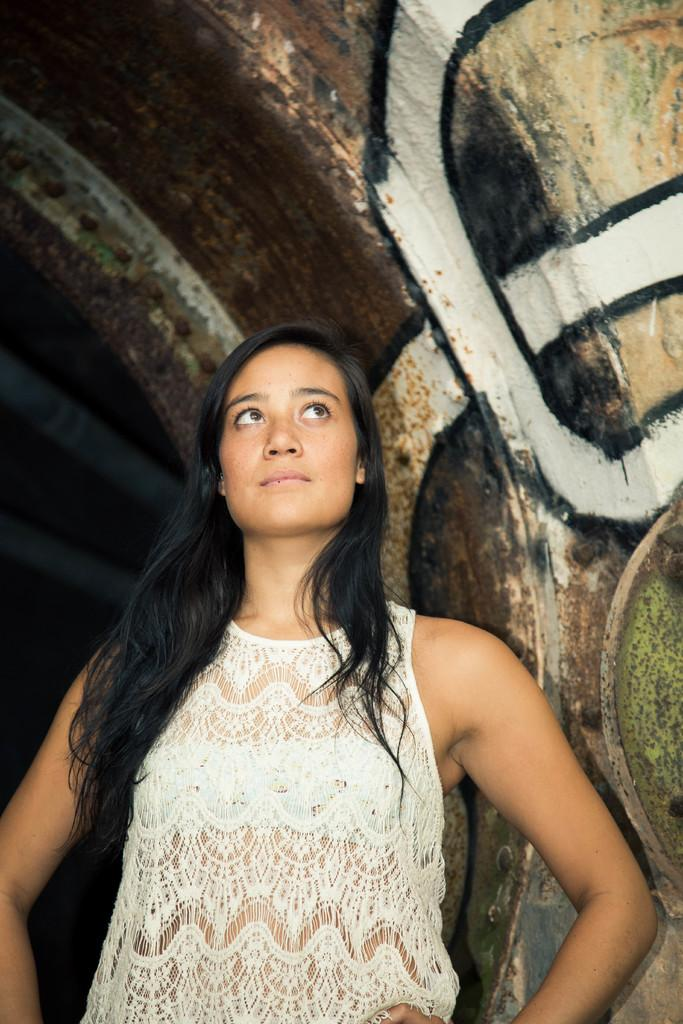Who is the main subject in the foreground of the image? There is a woman standing in the foreground of the image. What is the woman doing in the image? The woman is looking up in the image. What can be seen in the background of the image? There is a wall with graffiti painting in the background of the image. What type of fight is happening in the image? There is no fight present in the image. What color are the woman's eyes in the image? The color of the woman's eyes is not mentioned in the provided facts. 